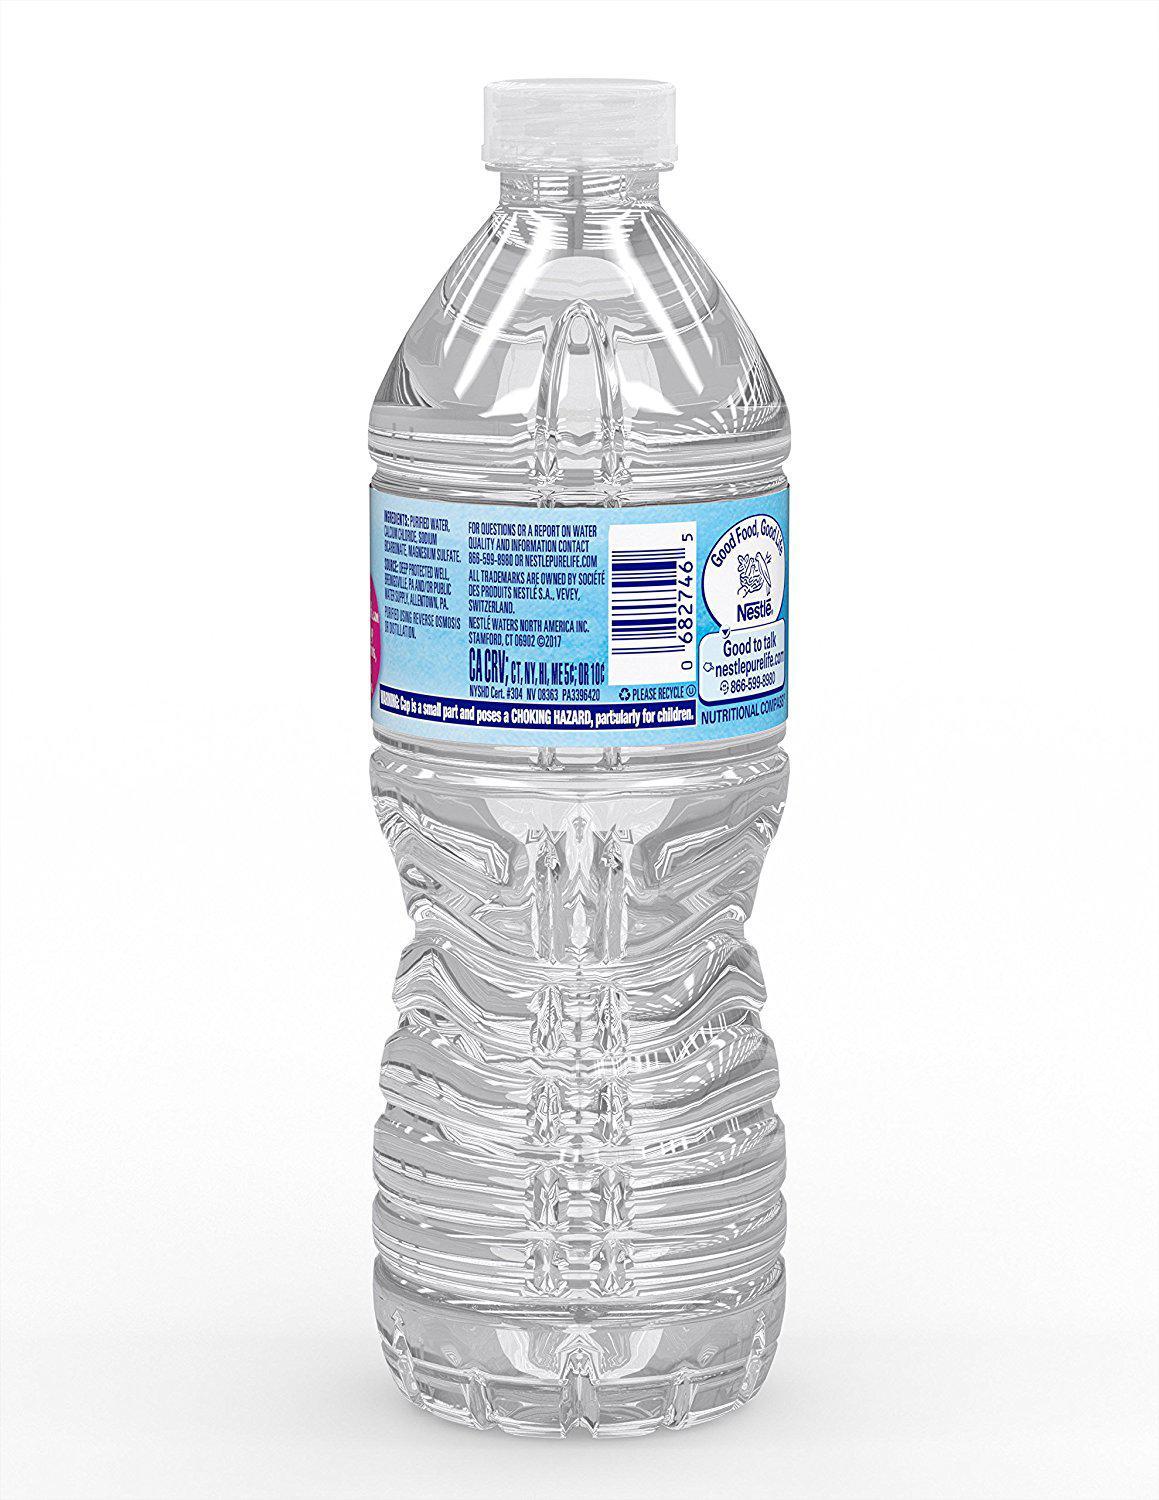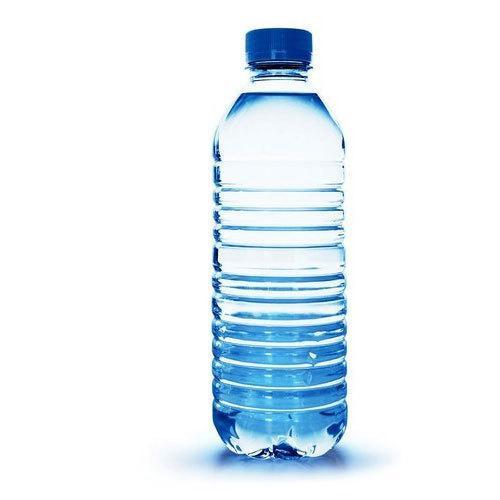The first image is the image on the left, the second image is the image on the right. For the images displayed, is the sentence "One image contains a single upright bottle with an indented 'hourglass' ribbed bottom, a paper label and a white lid, and the other image includes an upright blue-lidded label-less bottled with ribbing but no 'hourglass' indentation." factually correct? Answer yes or no. Yes. The first image is the image on the left, the second image is the image on the right. Evaluate the accuracy of this statement regarding the images: "There are exactly two bottles.". Is it true? Answer yes or no. Yes. 